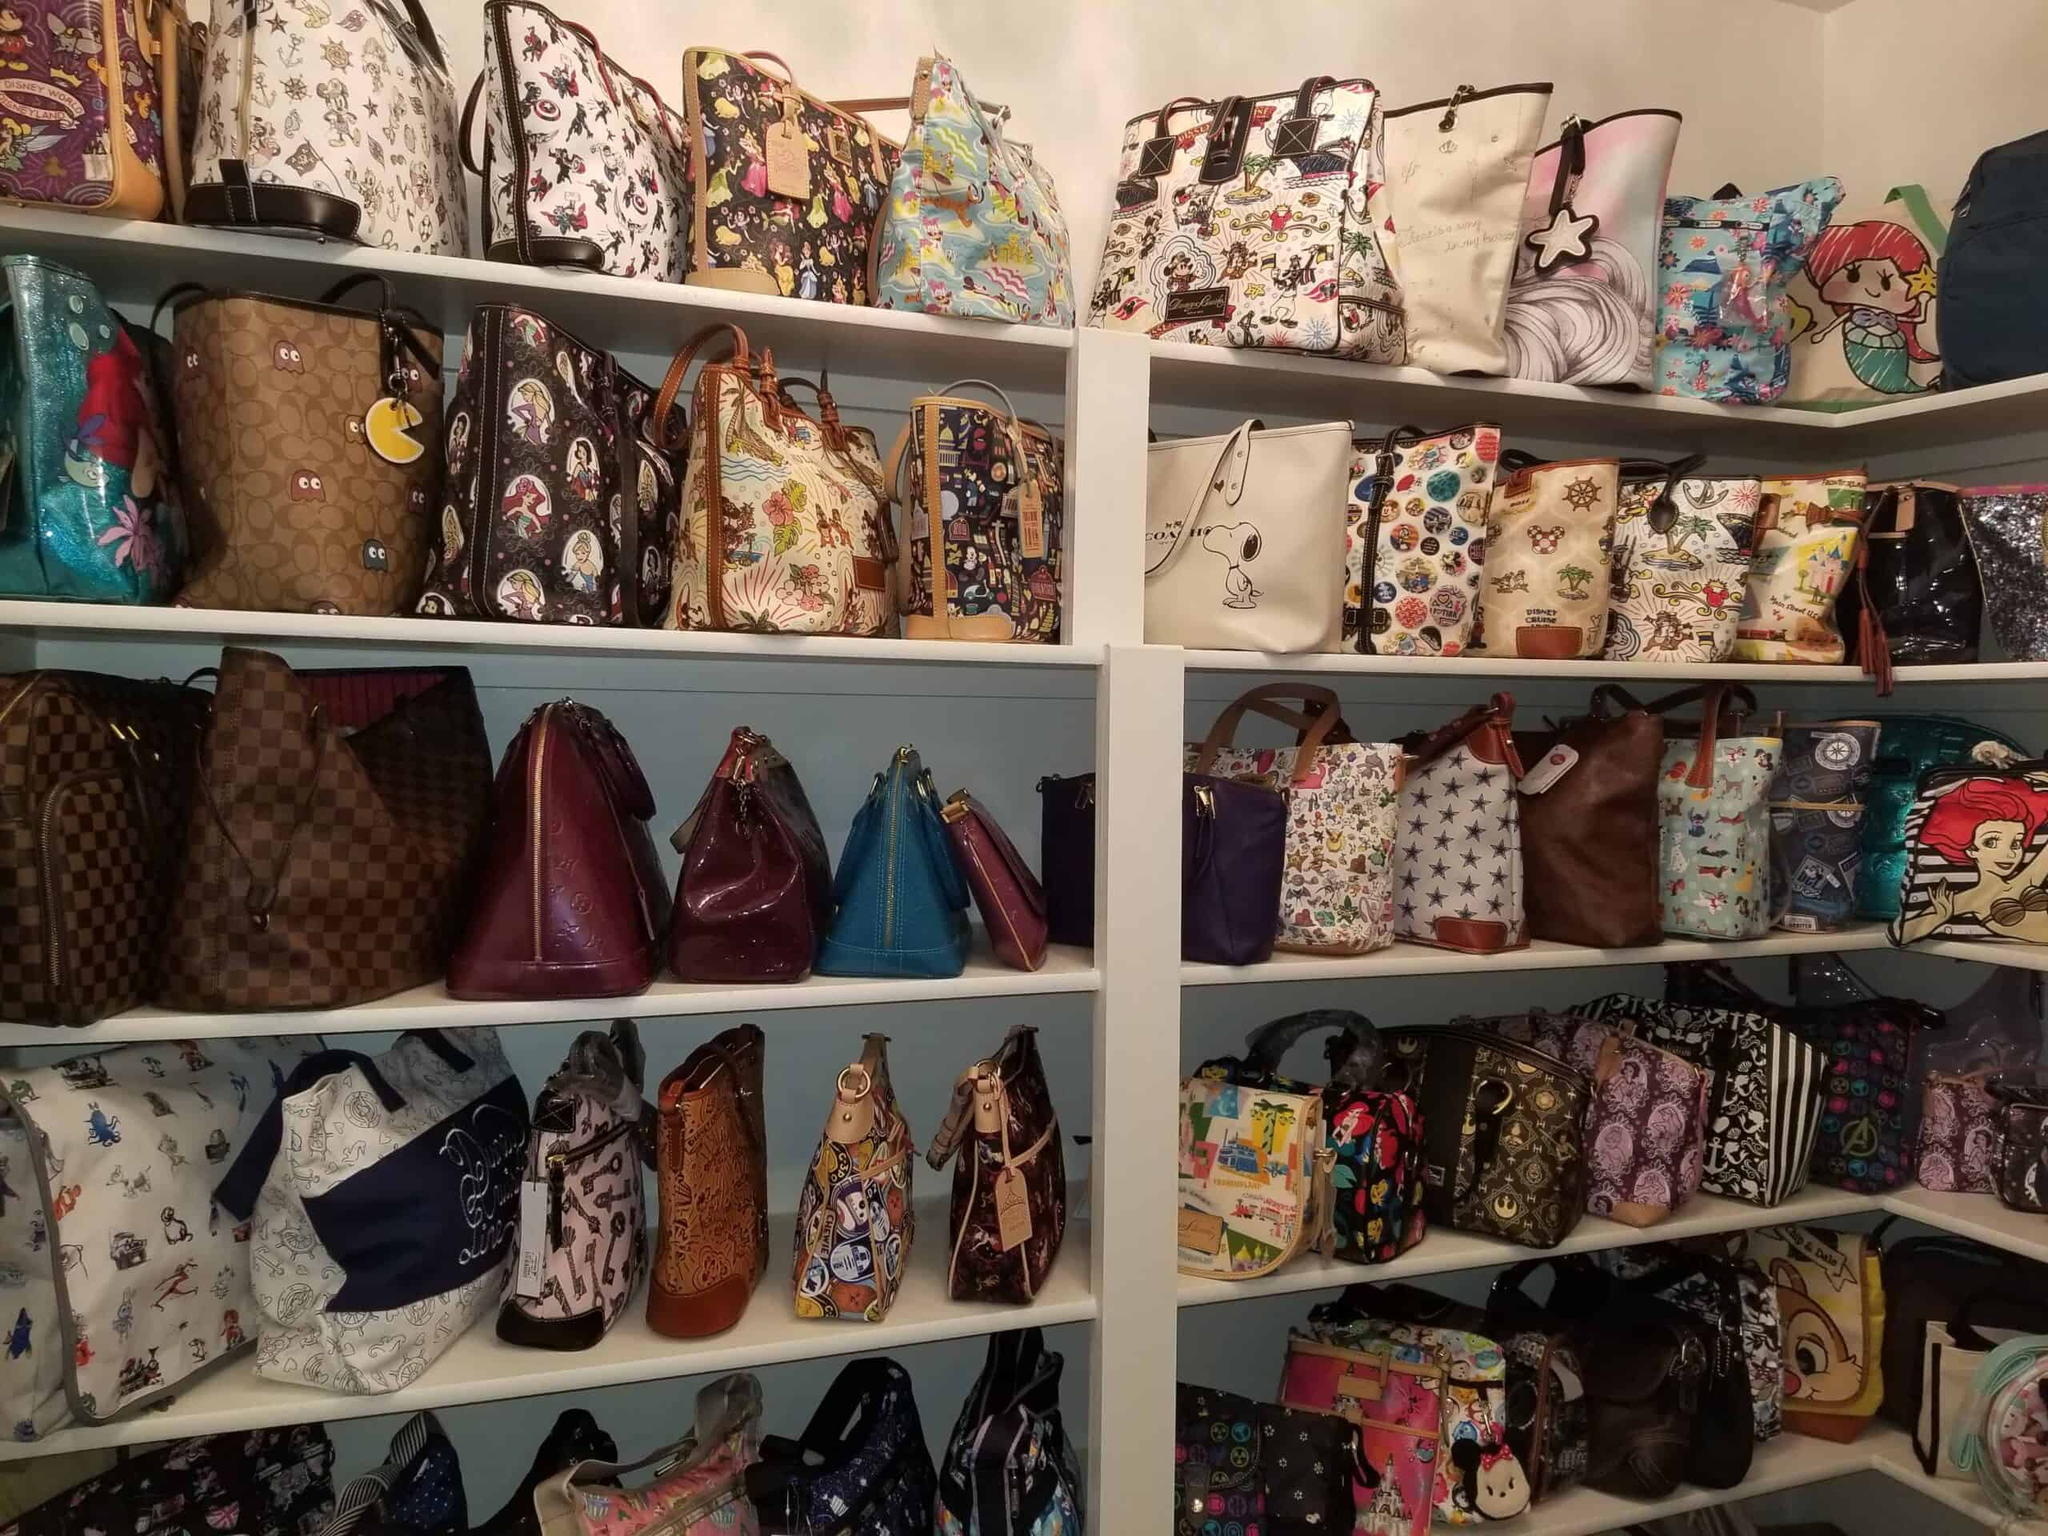Imagine you are designing a new bag to fit into this collection. What would it look like, and what character or theme would you choose? For a new bag to fit into this vibrant collection, I would design a bag that features a mash-up of characters from various animated shows and movies, creating a unique 'crossover' theme. The front of the bag would have a dynamic scene where different characters interact in a fantasy world. The color palette would be bold and varied to stand out yet harmonize with the other bags. I would incorporate characters like Harry Potter, Pikachu, and Wonder Woman meeting on an adventure, emphasizing unity and collaboration in the imaginative world. The bag would be practical with multiple compartments and embellished with playful details like character-shaped zipper pulls and adjustable straps featuring themed patterns. 